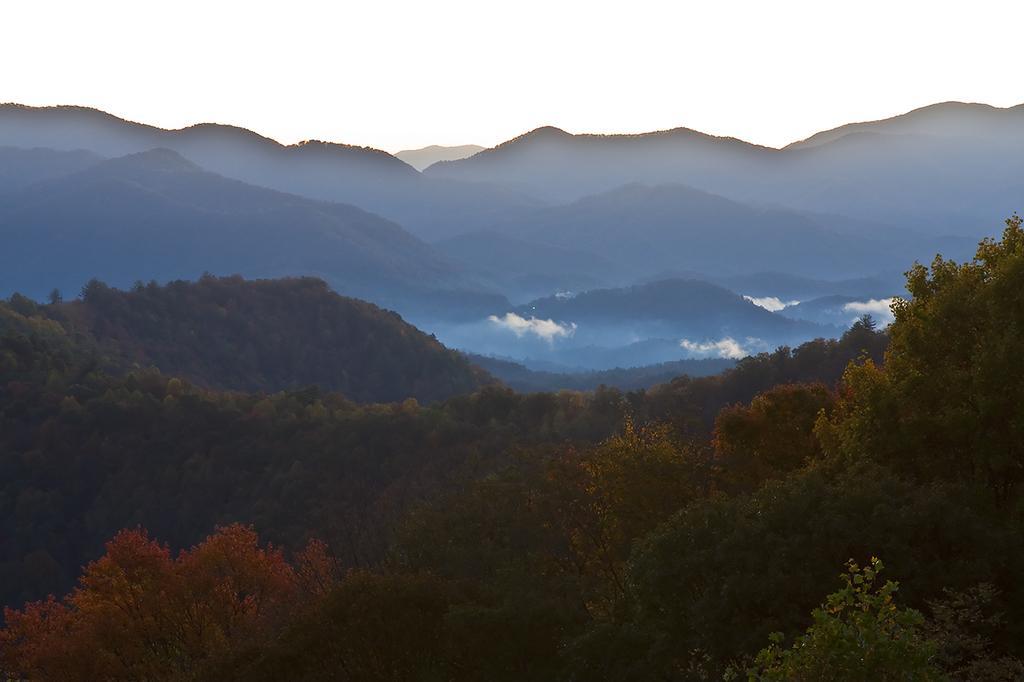Can you describe this image briefly? We can see trees and mountain. We can see sky. 